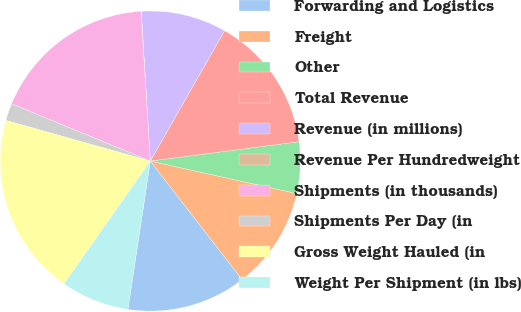Convert chart. <chart><loc_0><loc_0><loc_500><loc_500><pie_chart><fcel>Forwarding and Logistics<fcel>Freight<fcel>Other<fcel>Total Revenue<fcel>Revenue (in millions)<fcel>Revenue Per Hundredweight<fcel>Shipments (in thousands)<fcel>Shipments Per Day (in<fcel>Gross Weight Hauled (in<fcel>Weight Per Shipment (in lbs)<nl><fcel>12.87%<fcel>11.04%<fcel>5.53%<fcel>14.7%<fcel>9.2%<fcel>0.03%<fcel>17.78%<fcel>1.87%<fcel>19.61%<fcel>7.37%<nl></chart> 